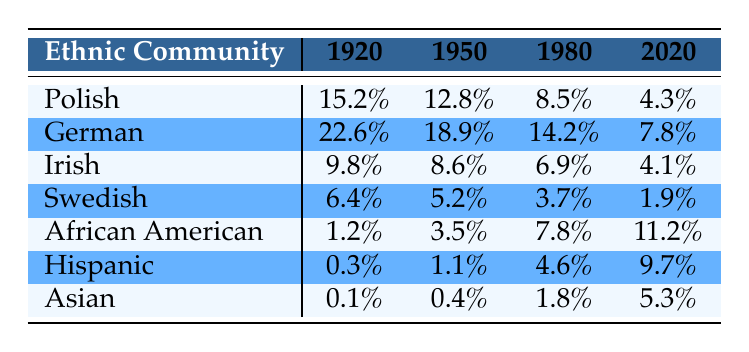What was the percentage of the Polish community in 1920? The table shows that the Polish community made up 15.2% of the population in 1920.
Answer: 15.2% Which ethnic community had the highest percentage in 1950? Referring to the table, the German community had the highest percentage at 22.6% in 1950.
Answer: German What is the difference in percentage of the African American population from 1980 to 2020? The African American population was 7.8% in 1980 and increased to 11.2% in 2020. The difference is 11.2% - 7.8% = 3.4%.
Answer: 3.4% Did the percentage of the Hispanic community increase over the years? By looking at the table, the percentage of the Hispanic community increased from 0.3% in 1920 to 9.7% in 2020. Therefore, the answer is yes.
Answer: Yes What was the average percentage of the Irish and Swedish communities in 1980? In 1980, the Irish percentage was 6.9% and the Swedish percentage was 3.7%. Summing these gives 6.9% + 3.7% = 10.6%. To find the average, divide by 2, resulting in 10.6% / 2 = 5.3%.
Answer: 5.3% Which ethnic community experienced the most significant decline from 1920 to 2020? The Polish community decreased from 15.2% in 1920 to 4.3% in 2020, which is a decline of 10.9%. The German community also declined, but not as much (22.6% to 7.8%, a decline of 14.8%). The Irish and Swedish communities also saw declines, but the Polish had the most notable drop.
Answer: Polish What percentage of the Asian community was recorded in 1950? According to the table, the percentage of the Asian community in 1950 was 0.4%.
Answer: 0.4% Is the percentage of the Irish community lower in 2020 than in 1920? The percentage of the Irish community was 9.8% in 1920 and 4.1% in 2020. Thus, the percentage in 2020 is lower, confirming the answer as yes.
Answer: Yes 